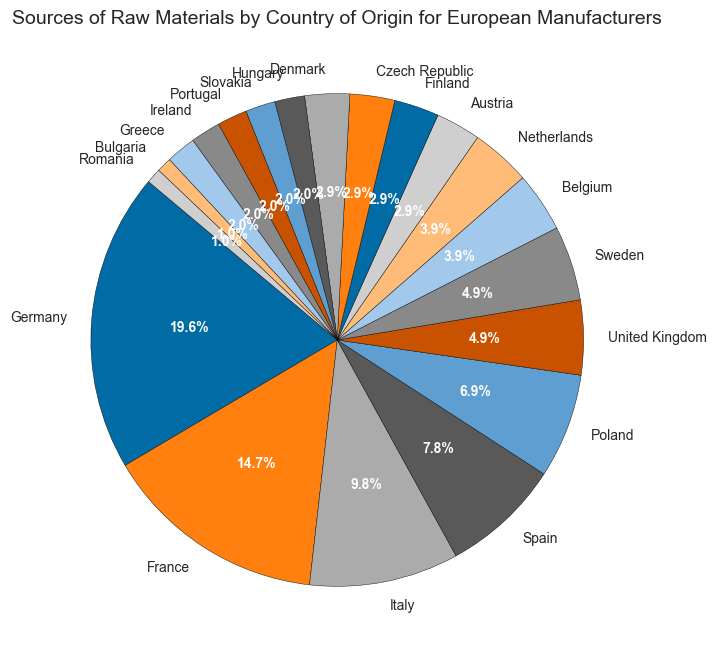Which country is the largest source of raw materials for European manufacturers? The largest slice of the pie chart corresponds to Germany, which has the highest percentage of raw materials.
Answer: Germany How many countries provide exactly 5% of the raw materials? By looking at the pie chart, we find that both Sweden and the United Kingdom have equal-sized slices showing 5% each.
Answer: 2 What is the combined raw material percentage from France and Italy? France has 15% and Italy has 10%, so their combined total is 15% + 10% = 25%.
Answer: 25% Which country provides a smaller percentage of raw materials: Finland or Romania? By inspecting their respective slices, Finland provides 3% while Romania provides 1%, so Romania provides a smaller percentage.
Answer: Romania What is the difference in raw material percentage between Spain and Poland? Spain provides 8% and Poland provides 7%. The difference is 8% - 7% = 1%.
Answer: 1 How many countries contribute 3% each to the raw materials? By analyzing the pie chart, we find that Austria, Finland, Czech Republic, and Denmark each contribute exactly 3%. Therefore, there are 4 such countries.
Answer: 4 Which countries' slices combined make up the same percentage as Germany's? Germany's slice makes up 20%. Combining Spain (8%), Poland (7%), and United Kingdom (5%) gives 8% + 7% + 5% = 20%.
Answer: Spain, Poland, United Kingdom What is the combined percentage of raw materials sourced from Belgium, Netherlands, Denmark, and Hungary? Belgium has 4%, Netherlands has 4%, Denmark has 3%, and Hungary has 2%. Combine these to get 4% + 4% + 3% + 2% = 13%.
Answer: 13% Which country contributes more raw materials: Greece or Bulgaria? Greece contributes 2% while Bulgaria contributes 1%, so Greece contributes more.
Answer: Greece What is the difference in percentage between the country with the highest contribution and the country with the lowest contribution? Germany has the highest contribution with 20%, and both Bulgaria and Romania are the lowest contributors with 1% each. The difference is 20% - 1% = 19%.
Answer: 19 